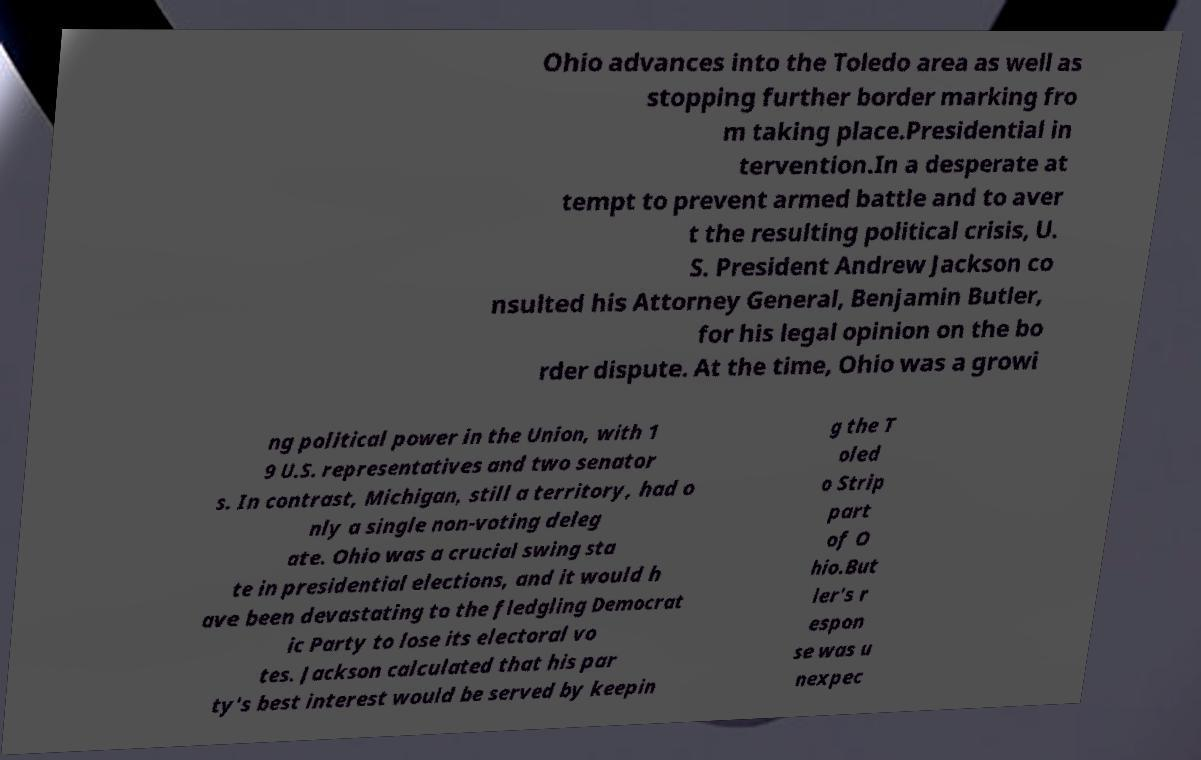For documentation purposes, I need the text within this image transcribed. Could you provide that? Ohio advances into the Toledo area as well as stopping further border marking fro m taking place.Presidential in tervention.In a desperate at tempt to prevent armed battle and to aver t the resulting political crisis, U. S. President Andrew Jackson co nsulted his Attorney General, Benjamin Butler, for his legal opinion on the bo rder dispute. At the time, Ohio was a growi ng political power in the Union, with 1 9 U.S. representatives and two senator s. In contrast, Michigan, still a territory, had o nly a single non-voting deleg ate. Ohio was a crucial swing sta te in presidential elections, and it would h ave been devastating to the fledgling Democrat ic Party to lose its electoral vo tes. Jackson calculated that his par ty's best interest would be served by keepin g the T oled o Strip part of O hio.But ler's r espon se was u nexpec 